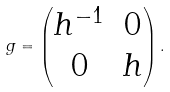Convert formula to latex. <formula><loc_0><loc_0><loc_500><loc_500>g = \begin{pmatrix} h ^ { - 1 } & 0 \\ 0 & h \\ \end{pmatrix} .</formula> 